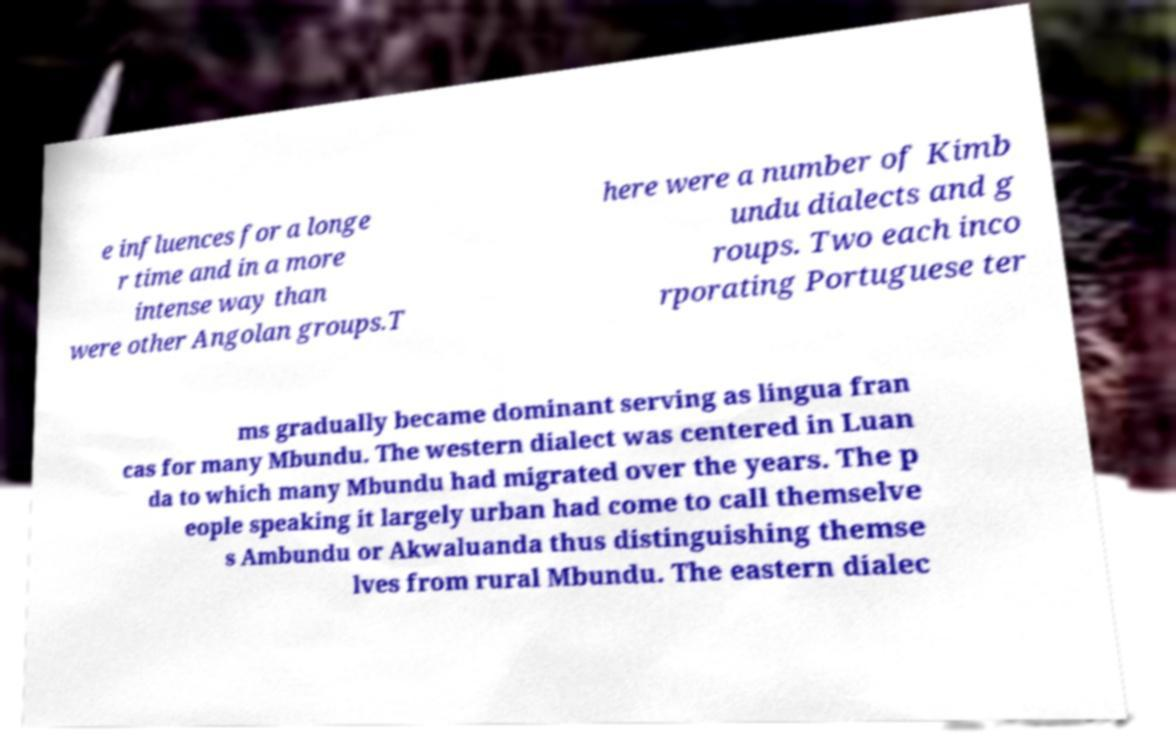There's text embedded in this image that I need extracted. Can you transcribe it verbatim? e influences for a longe r time and in a more intense way than were other Angolan groups.T here were a number of Kimb undu dialects and g roups. Two each inco rporating Portuguese ter ms gradually became dominant serving as lingua fran cas for many Mbundu. The western dialect was centered in Luan da to which many Mbundu had migrated over the years. The p eople speaking it largely urban had come to call themselve s Ambundu or Akwaluanda thus distinguishing themse lves from rural Mbundu. The eastern dialec 